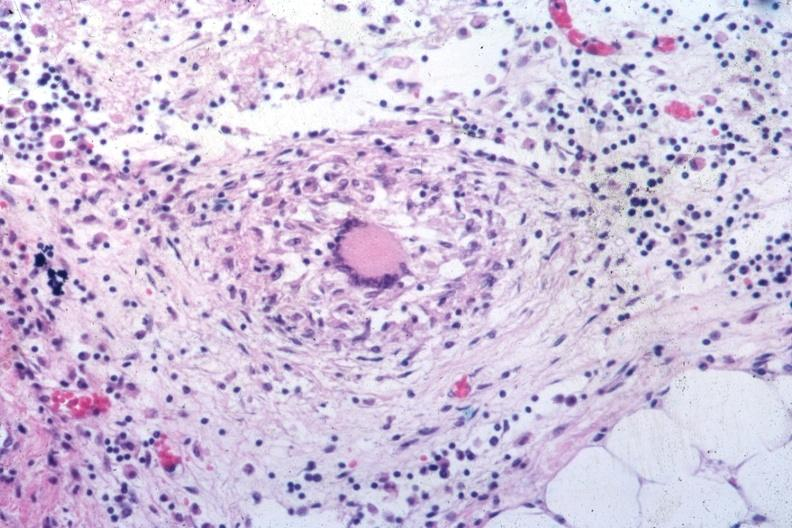what is present?
Answer the question using a single word or phrase. Peritoneum 